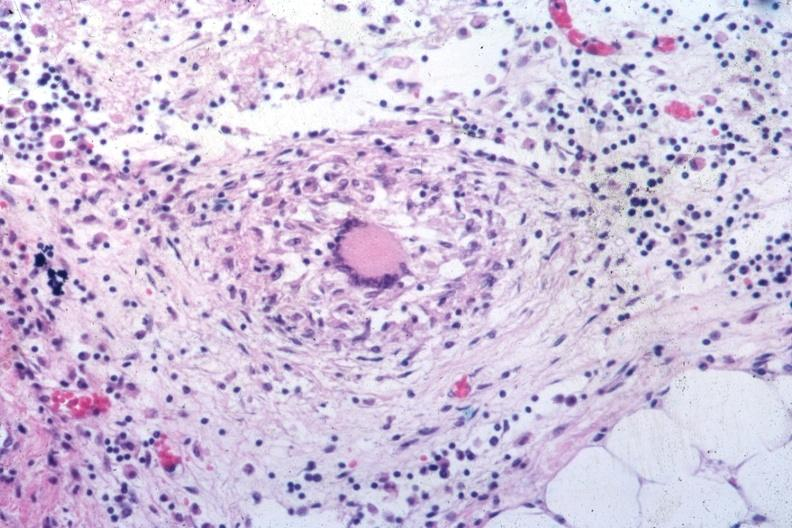what is present?
Answer the question using a single word or phrase. Peritoneum 